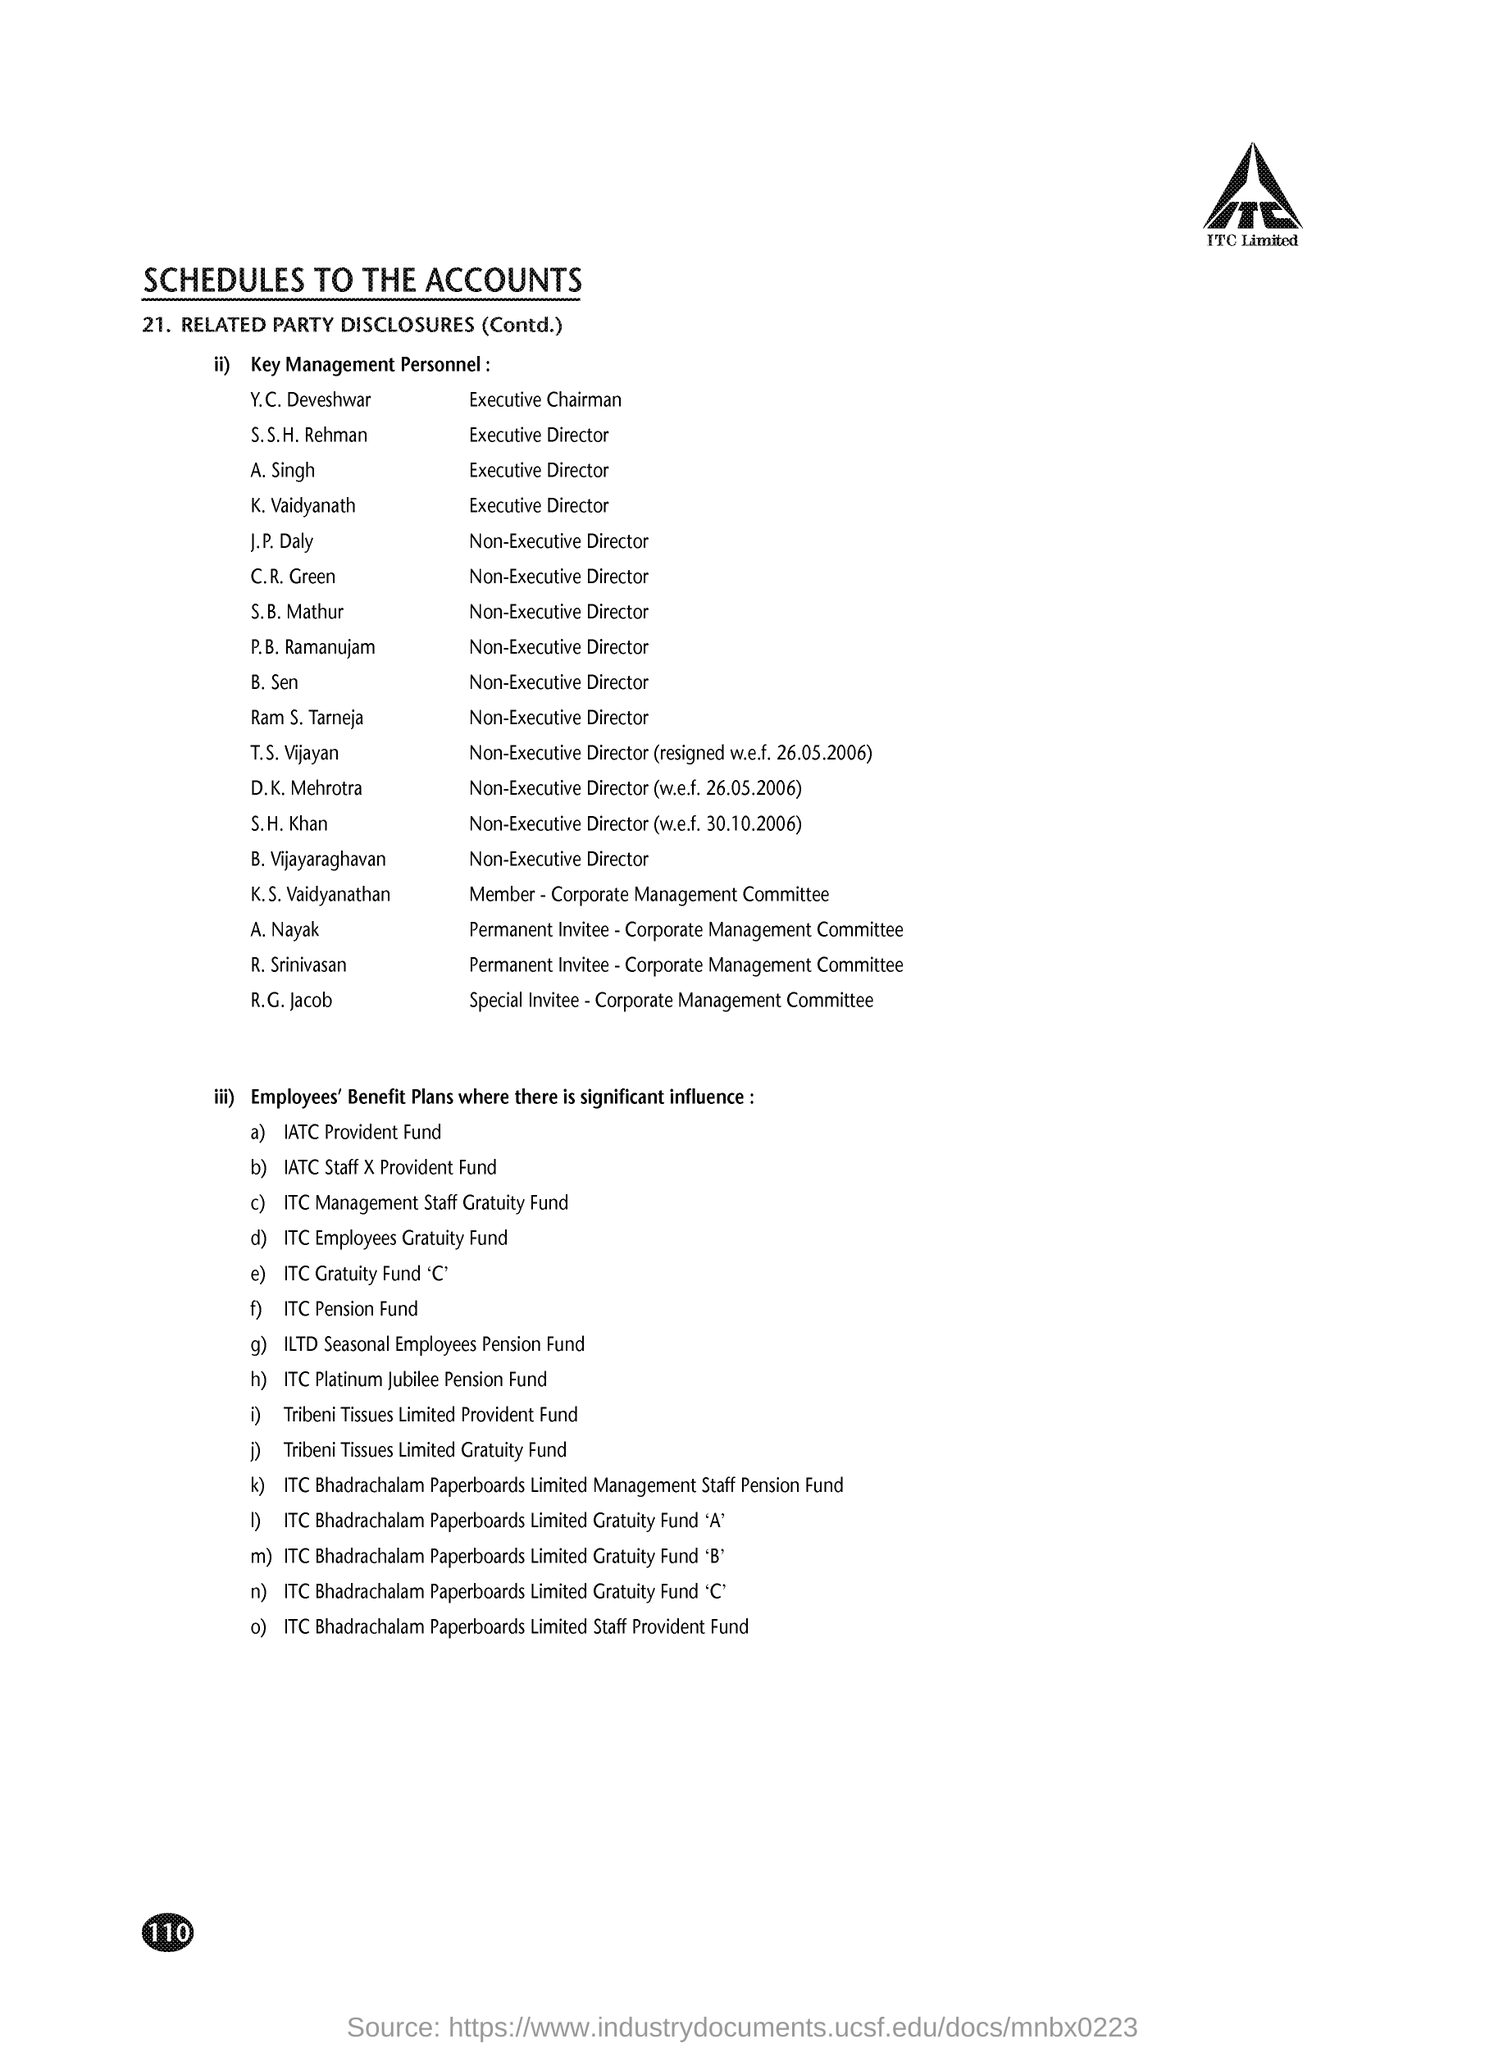Which company is mentioned in the header of the document?
Make the answer very short. ITC. What is the Designation of S. S. H. Rehman?
Offer a terse response. Executive Director. 